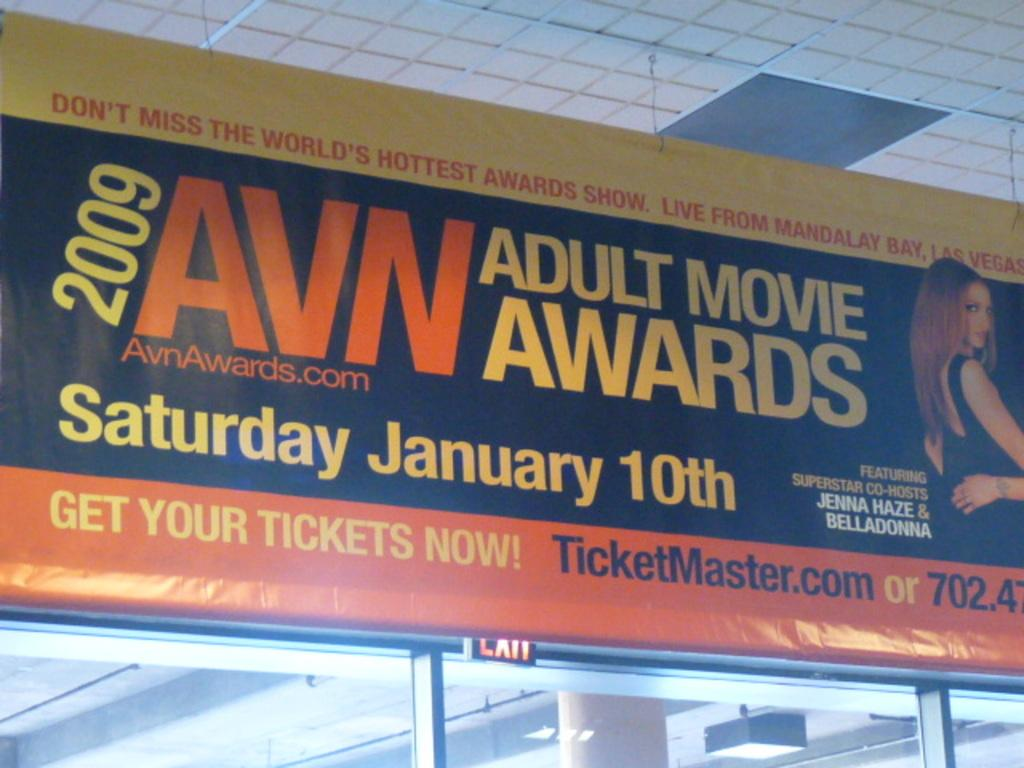<image>
Present a compact description of the photo's key features. The sign is advertising the 2009 Adult Movie Awards taking place at Mandalay Bay in Vegas. 